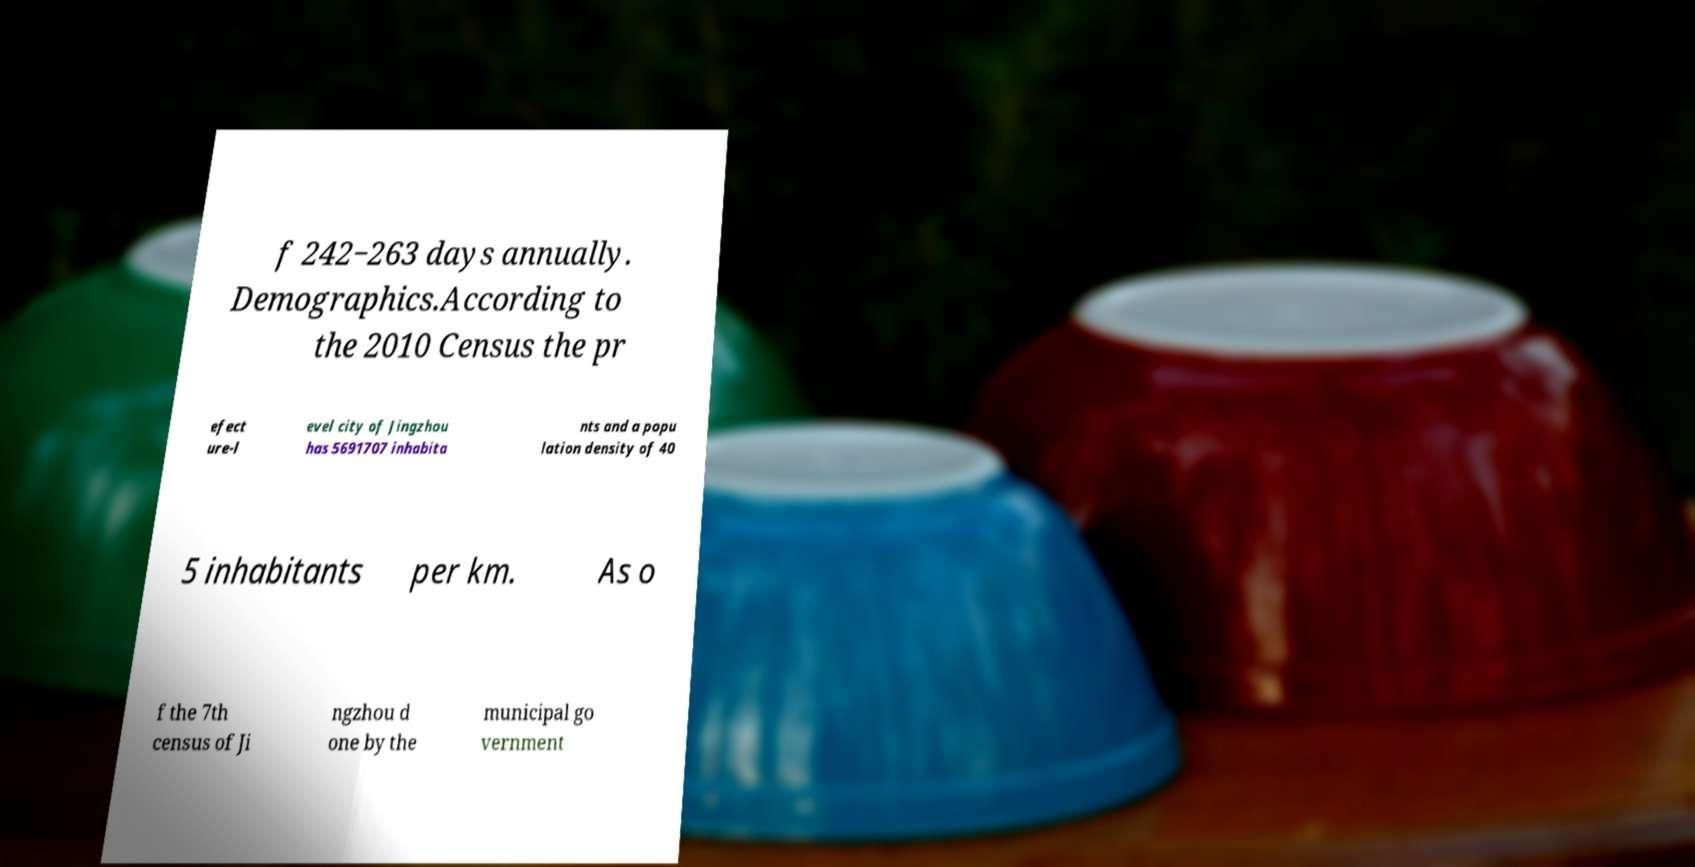Please read and relay the text visible in this image. What does it say? f 242−263 days annually. Demographics.According to the 2010 Census the pr efect ure-l evel city of Jingzhou has 5691707 inhabita nts and a popu lation density of 40 5 inhabitants per km. As o f the 7th census of Ji ngzhou d one by the municipal go vernment 